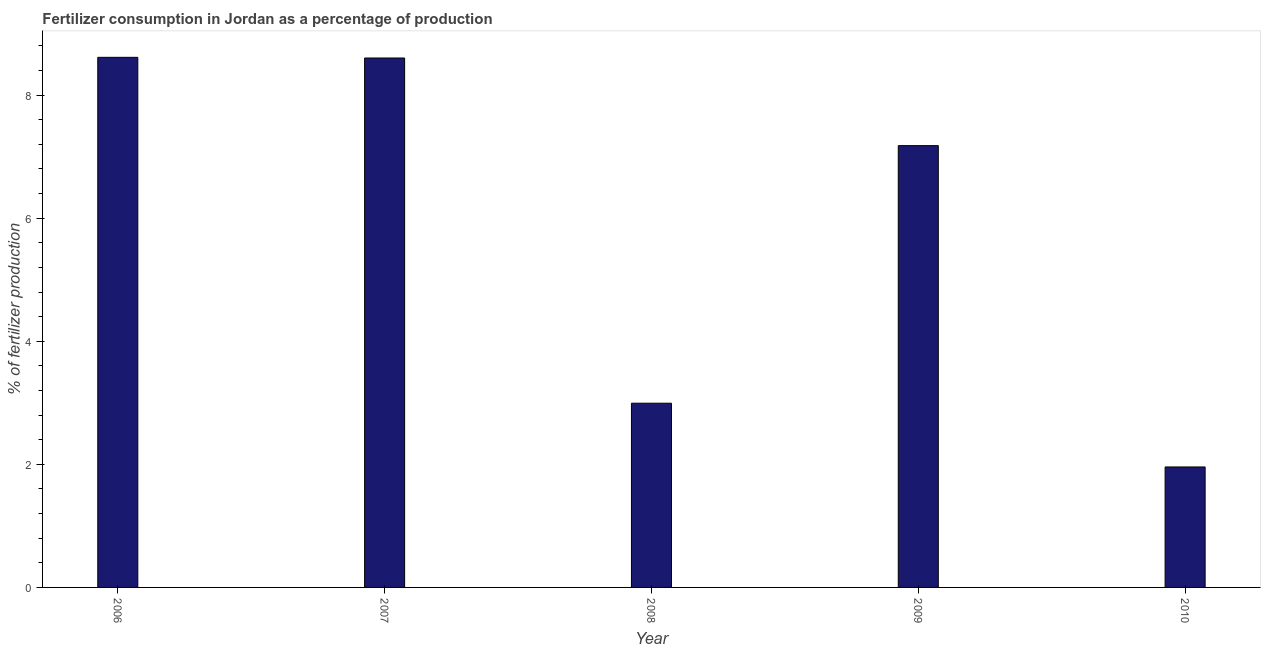Does the graph contain any zero values?
Provide a short and direct response. No. Does the graph contain grids?
Offer a terse response. No. What is the title of the graph?
Offer a very short reply. Fertilizer consumption in Jordan as a percentage of production. What is the label or title of the X-axis?
Ensure brevity in your answer.  Year. What is the label or title of the Y-axis?
Offer a terse response. % of fertilizer production. What is the amount of fertilizer consumption in 2010?
Your answer should be compact. 1.96. Across all years, what is the maximum amount of fertilizer consumption?
Keep it short and to the point. 8.61. Across all years, what is the minimum amount of fertilizer consumption?
Provide a succinct answer. 1.96. In which year was the amount of fertilizer consumption minimum?
Give a very brief answer. 2010. What is the sum of the amount of fertilizer consumption?
Your answer should be very brief. 29.35. What is the difference between the amount of fertilizer consumption in 2007 and 2009?
Provide a short and direct response. 1.42. What is the average amount of fertilizer consumption per year?
Your response must be concise. 5.87. What is the median amount of fertilizer consumption?
Provide a short and direct response. 7.18. What is the ratio of the amount of fertilizer consumption in 2009 to that in 2010?
Your answer should be compact. 3.67. Is the difference between the amount of fertilizer consumption in 2008 and 2010 greater than the difference between any two years?
Offer a very short reply. No. What is the difference between the highest and the second highest amount of fertilizer consumption?
Give a very brief answer. 0.01. Is the sum of the amount of fertilizer consumption in 2008 and 2010 greater than the maximum amount of fertilizer consumption across all years?
Ensure brevity in your answer.  No. What is the difference between the highest and the lowest amount of fertilizer consumption?
Give a very brief answer. 6.66. In how many years, is the amount of fertilizer consumption greater than the average amount of fertilizer consumption taken over all years?
Give a very brief answer. 3. How many years are there in the graph?
Provide a succinct answer. 5. What is the difference between two consecutive major ticks on the Y-axis?
Your answer should be compact. 2. Are the values on the major ticks of Y-axis written in scientific E-notation?
Provide a short and direct response. No. What is the % of fertilizer production of 2006?
Your answer should be very brief. 8.61. What is the % of fertilizer production of 2007?
Your answer should be very brief. 8.6. What is the % of fertilizer production of 2008?
Keep it short and to the point. 2.99. What is the % of fertilizer production in 2009?
Provide a short and direct response. 7.18. What is the % of fertilizer production in 2010?
Make the answer very short. 1.96. What is the difference between the % of fertilizer production in 2006 and 2007?
Your answer should be very brief. 0.01. What is the difference between the % of fertilizer production in 2006 and 2008?
Provide a succinct answer. 5.62. What is the difference between the % of fertilizer production in 2006 and 2009?
Offer a very short reply. 1.43. What is the difference between the % of fertilizer production in 2006 and 2010?
Provide a short and direct response. 6.66. What is the difference between the % of fertilizer production in 2007 and 2008?
Ensure brevity in your answer.  5.61. What is the difference between the % of fertilizer production in 2007 and 2009?
Give a very brief answer. 1.42. What is the difference between the % of fertilizer production in 2007 and 2010?
Make the answer very short. 6.65. What is the difference between the % of fertilizer production in 2008 and 2009?
Your answer should be very brief. -4.19. What is the difference between the % of fertilizer production in 2008 and 2010?
Your answer should be very brief. 1.04. What is the difference between the % of fertilizer production in 2009 and 2010?
Give a very brief answer. 5.22. What is the ratio of the % of fertilizer production in 2006 to that in 2007?
Ensure brevity in your answer.  1. What is the ratio of the % of fertilizer production in 2006 to that in 2008?
Your answer should be compact. 2.88. What is the ratio of the % of fertilizer production in 2006 to that in 2009?
Your answer should be compact. 1.2. What is the ratio of the % of fertilizer production in 2007 to that in 2008?
Offer a terse response. 2.87. What is the ratio of the % of fertilizer production in 2007 to that in 2009?
Keep it short and to the point. 1.2. What is the ratio of the % of fertilizer production in 2007 to that in 2010?
Keep it short and to the point. 4.39. What is the ratio of the % of fertilizer production in 2008 to that in 2009?
Offer a very short reply. 0.42. What is the ratio of the % of fertilizer production in 2008 to that in 2010?
Provide a short and direct response. 1.53. What is the ratio of the % of fertilizer production in 2009 to that in 2010?
Keep it short and to the point. 3.67. 